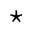<formula> <loc_0><loc_0><loc_500><loc_500>^ { * }</formula> 